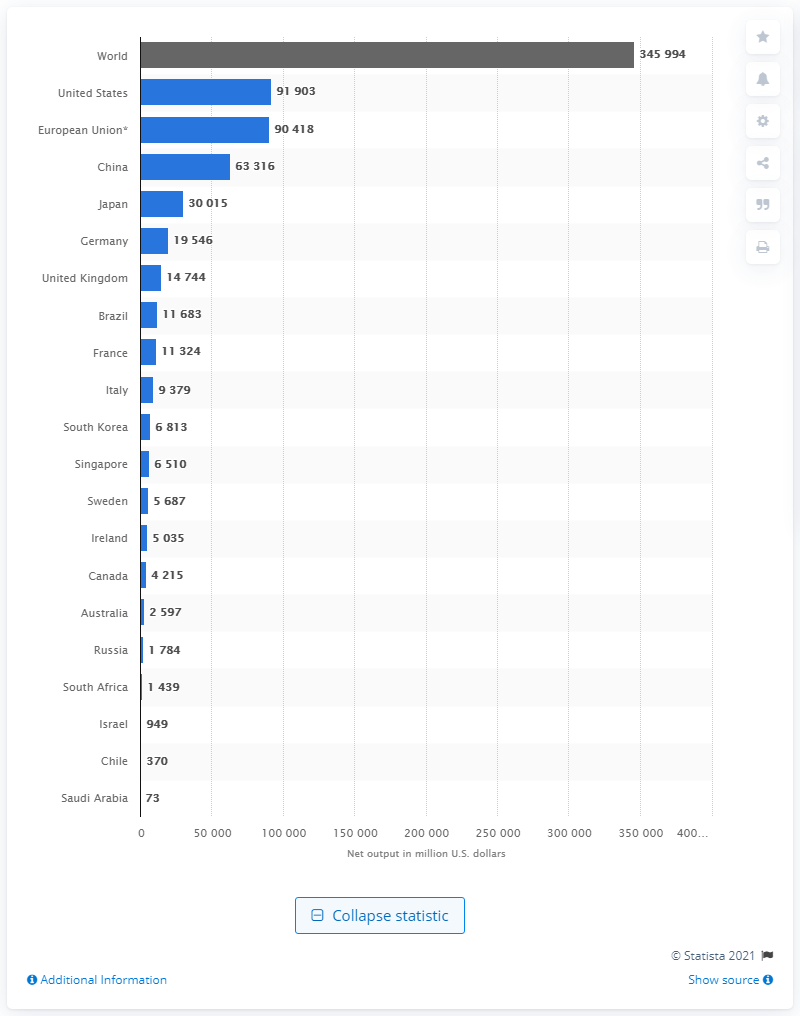What was the worldwide output of pharmaceuticals in 2010? The worldwide output of pharmaceuticals in 2010 cannot be accurately determined from this image alone, as it requires specific industry data from that year. However, the image displays pharmaceutical output statistics for various countries and regions, with the world total listed at the top. To provide the correct figure, one would need to consult historical data on global pharmaceutical production from a reliable source. 